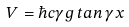Convert formula to latex. <formula><loc_0><loc_0><loc_500><loc_500>V = \hbar { c } \gamma g \, t a n \, \gamma x</formula> 